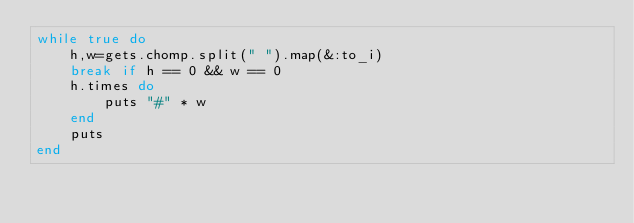Convert code to text. <code><loc_0><loc_0><loc_500><loc_500><_Ruby_>while true do
    h,w=gets.chomp.split(" ").map(&:to_i)
    break if h == 0 && w == 0
    h.times do
        puts "#" * w
    end
    puts
end
</code> 